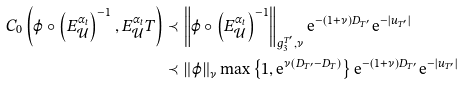Convert formula to latex. <formula><loc_0><loc_0><loc_500><loc_500>C _ { 0 } \left ( \varphi \circ \left ( E _ { \mathcal { U } } ^ { \alpha _ { t } } \right ) ^ { - 1 } , E _ { \mathcal { U } } ^ { \alpha _ { t } } T \right ) & \prec \left \| \varphi \circ \left ( E _ { \mathcal { U } } ^ { \alpha _ { t } } \right ) ^ { - 1 } \right \| _ { g _ { 3 } ^ { T ^ { \prime } } , \nu } \mathrm e ^ { - ( 1 + \nu ) D _ { T ^ { \prime } } } \mathrm e ^ { - \left | u _ { T ^ { \prime } } \right | } \\ & \prec \left \| \varphi \right \| _ { \nu } \max \left \{ 1 , \mathrm e ^ { \nu ( D _ { T ^ { \prime } } - D _ { T } ) } \right \} \mathrm e ^ { - ( 1 + \nu ) D _ { T ^ { \prime } } } \mathrm e ^ { - \left | u _ { T ^ { \prime } } \right | }</formula> 